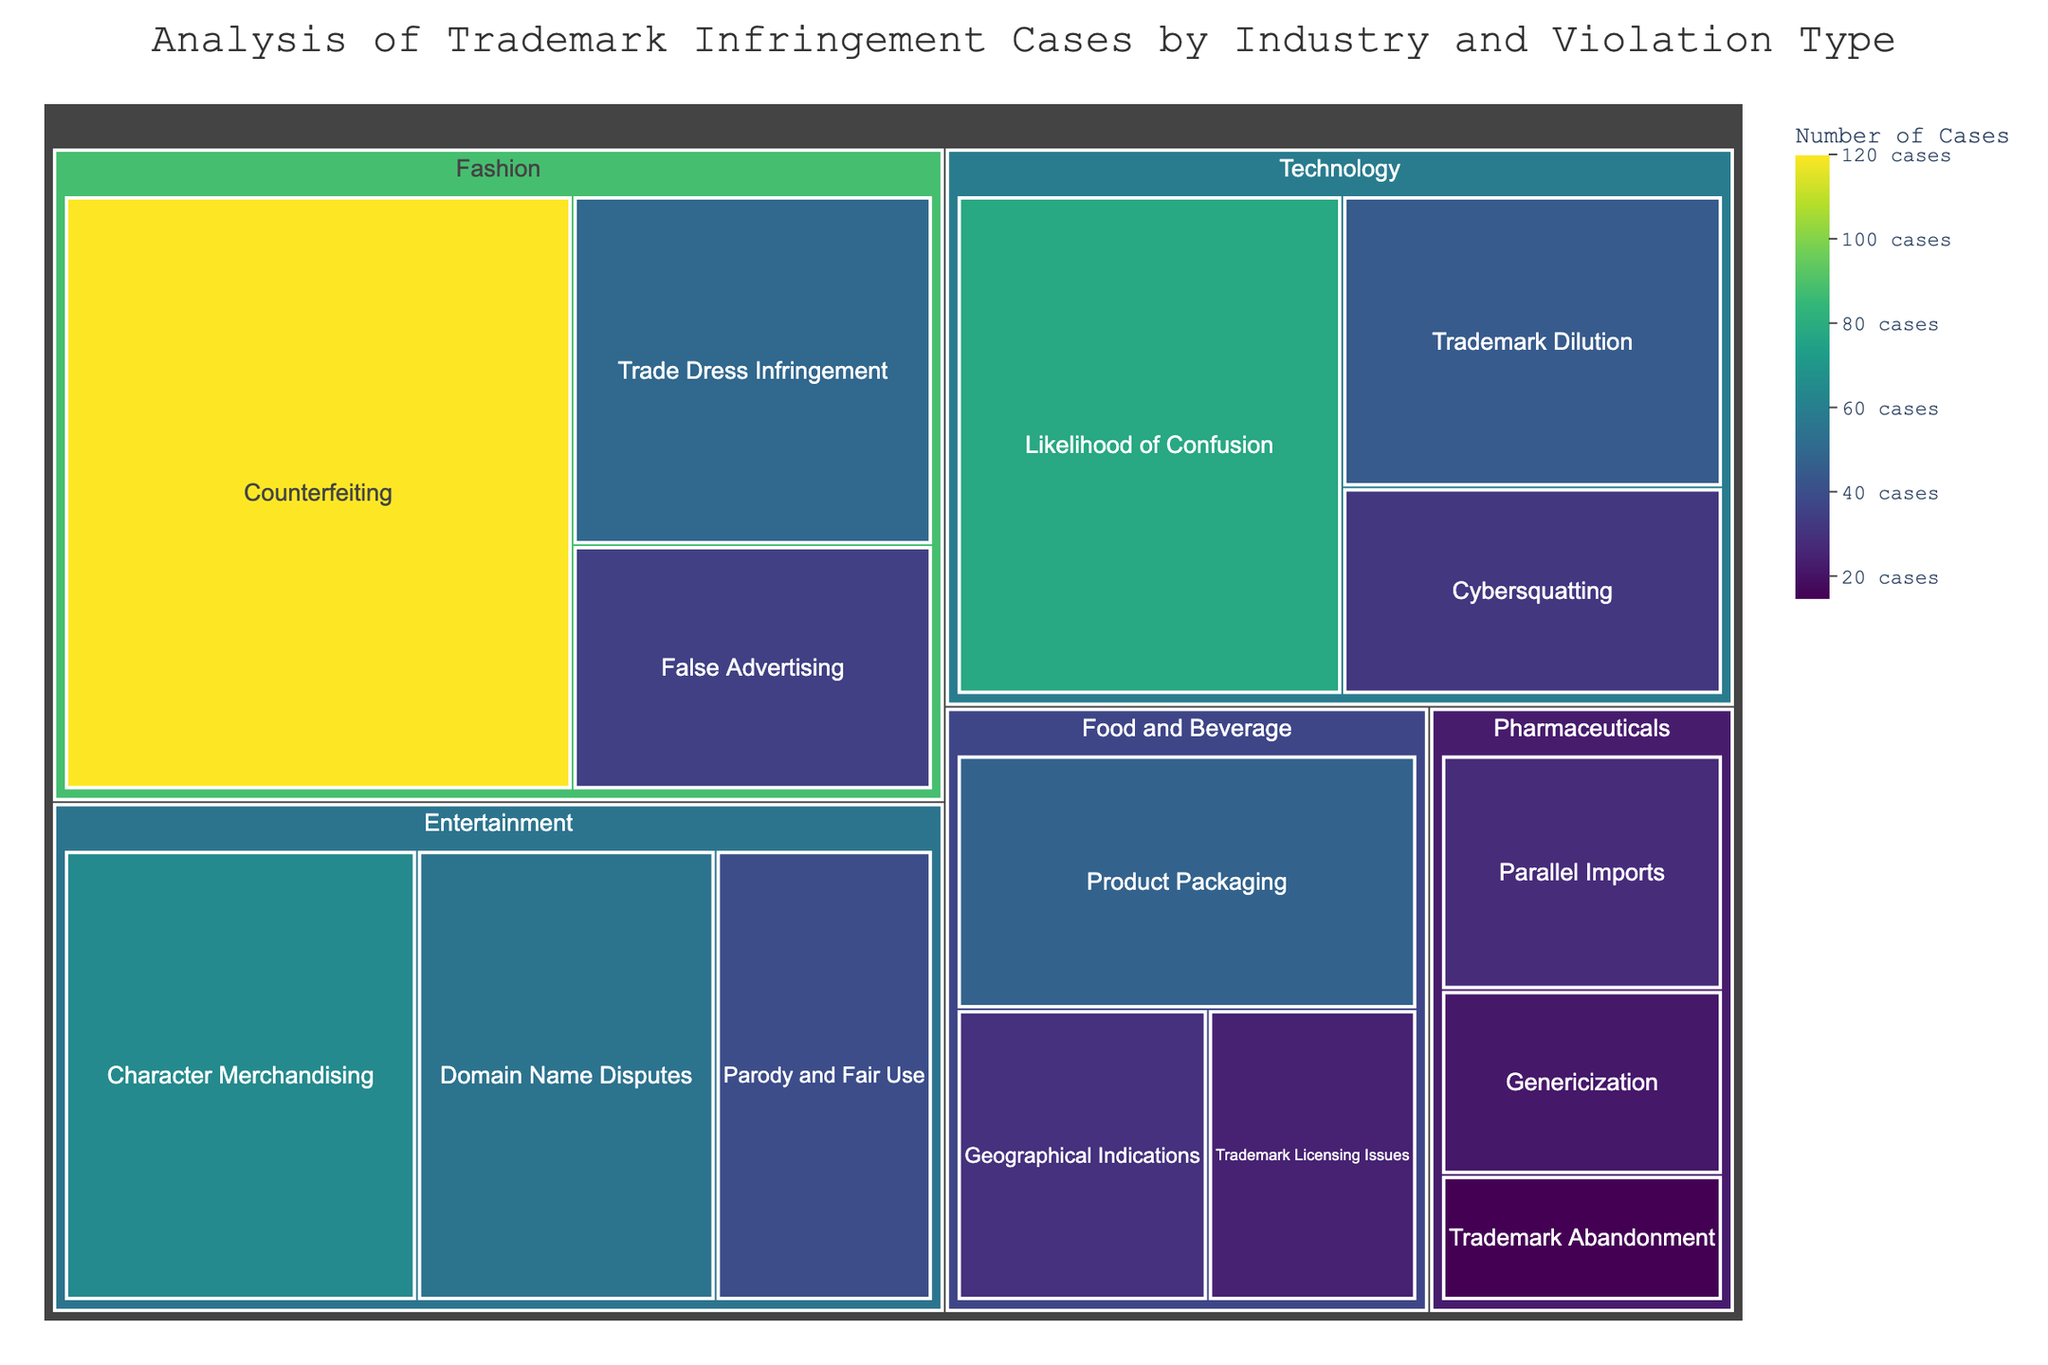What's the most common type of trademark infringement in the Fashion industry? First, locate the Fashion industry section in the treemap. Observe the types of violations and the corresponding number of cases. Counterfeiting has the highest number (120 cases).
Answer: Counterfeiting Which industry has the fewest trademark infringement cases? Examine all sections of the treemap and compare their total numbers. Note that Pharmaceuticals has the lowest combined total of cases.
Answer: Pharmaceuticals How many total infringement cases are there in the Technology industry? Sum up the cases in the Technology industry (45 for Trademark Dilution, 78 for Likelihood of Confusion, 32 for Cybersquatting).
Answer: 155 Which two industries have the highest number of cases for False Advertising and Parody and Fair Use combined? Identify the industries containing False Advertising (Fashion) with 35 cases and Parody and Fair Use (Entertainment) with 40 cases.
Answer: Fashion and Entertainment Is character merchandising infringement more common in the Entertainment industry than cybersquatting in Technology? Compare the number of cases for Character Merchandising in Entertainment (65 cases) and Cybersquatting in Technology (32 cases).
Answer: Yes What is the title of the figure? Read the title displayed at the top of the treemap.
Answer: Analysis of Trademark Infringement Cases by Industry and Violation Type Between Geographical Indications in Food and Beverage and Trade Dress Infringement in Fashion, which has fewer cases? Compare the number of cases of Geographical Indications in Food and Beverage (30 cases) and Trade Dress Infringement in Fashion (50 cases).
Answer: Geographical Indications Which color scale is used to represent the number of cases? Identify the continuous color scale referenced in the figure, which ranges from light to dark, often associated with the Viridis scale.
Answer: Viridis What is the sum of all trademark infringement cases in the Entertainment industry? Sum all the cases in Entertainment (65 for Character Merchandising, 40 for Parody and Fair Use, 55 for Domain Name Disputes).
Answer: 160 Does the Pharmaceuticals industry have more or fewer cases of trademark abandonment compared to trademark licensing issues in the Food and Beverage industry? Compare the number of cases of Trademark Abandonment in Pharmaceuticals (15 cases) with Trademark Licensing Issues in Food and Beverage (25 cases).
Answer: Fewer 